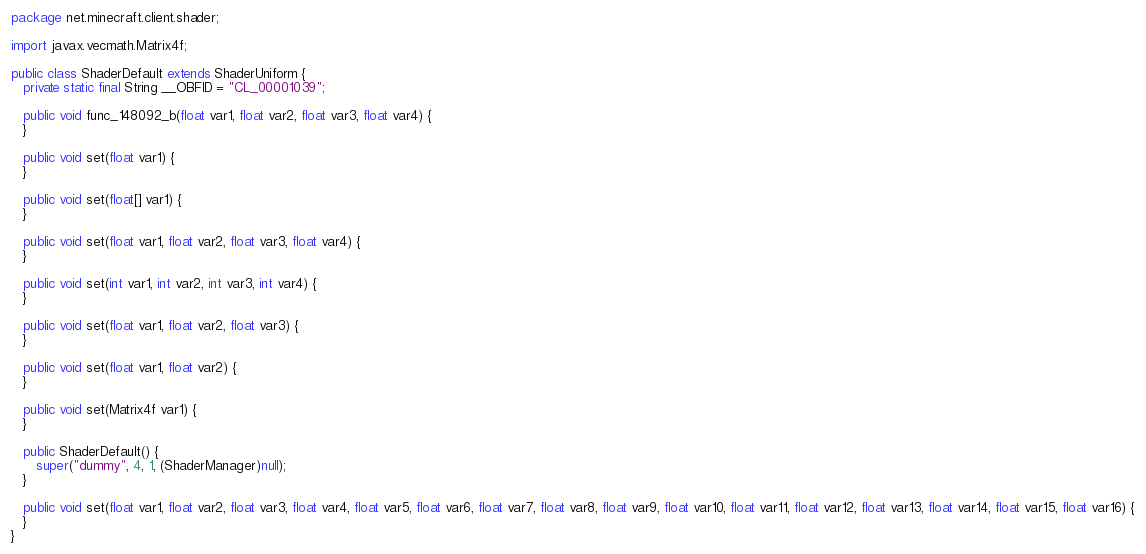<code> <loc_0><loc_0><loc_500><loc_500><_Java_>package net.minecraft.client.shader;

import javax.vecmath.Matrix4f;

public class ShaderDefault extends ShaderUniform {
   private static final String __OBFID = "CL_00001039";

   public void func_148092_b(float var1, float var2, float var3, float var4) {
   }

   public void set(float var1) {
   }

   public void set(float[] var1) {
   }

   public void set(float var1, float var2, float var3, float var4) {
   }

   public void set(int var1, int var2, int var3, int var4) {
   }

   public void set(float var1, float var2, float var3) {
   }

   public void set(float var1, float var2) {
   }

   public void set(Matrix4f var1) {
   }

   public ShaderDefault() {
      super("dummy", 4, 1, (ShaderManager)null);
   }

   public void set(float var1, float var2, float var3, float var4, float var5, float var6, float var7, float var8, float var9, float var10, float var11, float var12, float var13, float var14, float var15, float var16) {
   }
}
</code> 